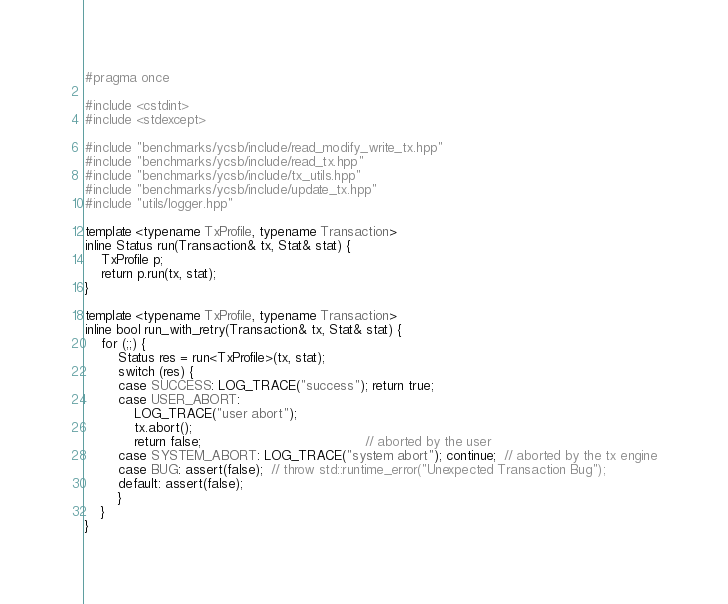Convert code to text. <code><loc_0><loc_0><loc_500><loc_500><_C++_>#pragma once

#include <cstdint>
#include <stdexcept>

#include "benchmarks/ycsb/include/read_modify_write_tx.hpp"
#include "benchmarks/ycsb/include/read_tx.hpp"
#include "benchmarks/ycsb/include/tx_utils.hpp"
#include "benchmarks/ycsb/include/update_tx.hpp"
#include "utils/logger.hpp"

template <typename TxProfile, typename Transaction>
inline Status run(Transaction& tx, Stat& stat) {
    TxProfile p;
    return p.run(tx, stat);
}

template <typename TxProfile, typename Transaction>
inline bool run_with_retry(Transaction& tx, Stat& stat) {
    for (;;) {
        Status res = run<TxProfile>(tx, stat);
        switch (res) {
        case SUCCESS: LOG_TRACE("success"); return true;
        case USER_ABORT:
            LOG_TRACE("user abort");
            tx.abort();
            return false;                                        // aborted by the user
        case SYSTEM_ABORT: LOG_TRACE("system abort"); continue;  // aborted by the tx engine
        case BUG: assert(false);  // throw std::runtime_error("Unexpected Transaction Bug");
        default: assert(false);
        }
    }
}
</code> 